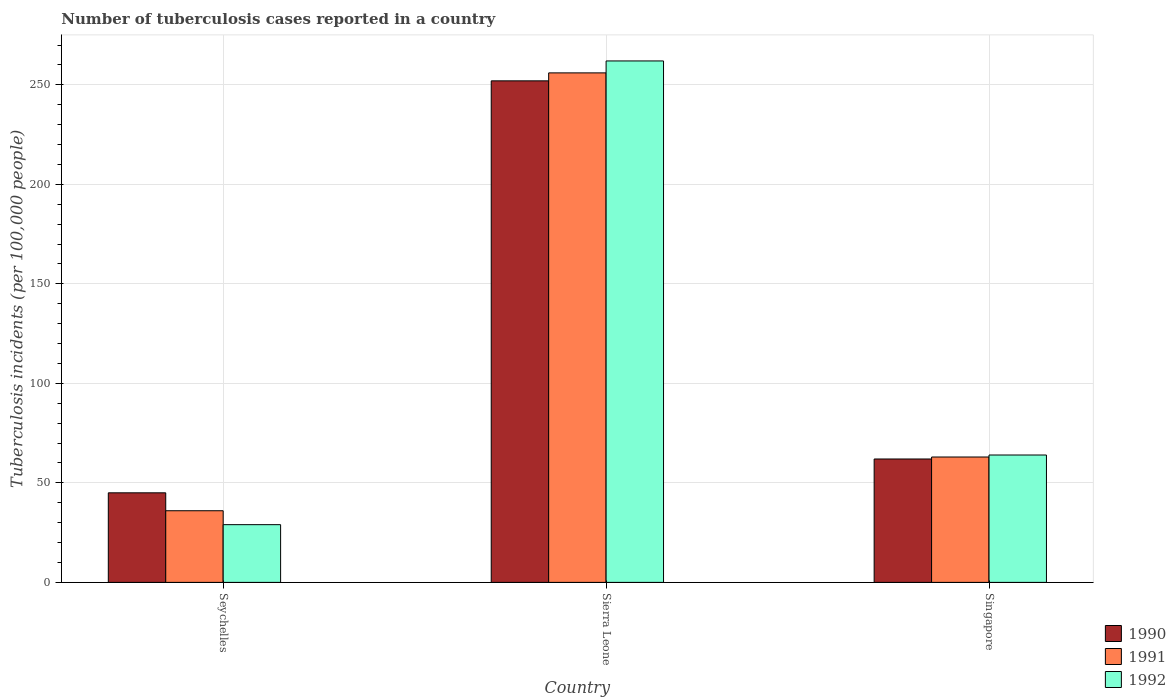Are the number of bars on each tick of the X-axis equal?
Your answer should be very brief. Yes. How many bars are there on the 2nd tick from the right?
Offer a very short reply. 3. What is the label of the 3rd group of bars from the left?
Your response must be concise. Singapore. In how many cases, is the number of bars for a given country not equal to the number of legend labels?
Offer a terse response. 0. What is the number of tuberculosis cases reported in in 1990 in Sierra Leone?
Your answer should be compact. 252. Across all countries, what is the maximum number of tuberculosis cases reported in in 1991?
Your answer should be compact. 256. Across all countries, what is the minimum number of tuberculosis cases reported in in 1990?
Ensure brevity in your answer.  45. In which country was the number of tuberculosis cases reported in in 1992 maximum?
Give a very brief answer. Sierra Leone. In which country was the number of tuberculosis cases reported in in 1990 minimum?
Offer a very short reply. Seychelles. What is the total number of tuberculosis cases reported in in 1992 in the graph?
Your response must be concise. 355. What is the difference between the number of tuberculosis cases reported in in 1992 in Seychelles and that in Sierra Leone?
Your response must be concise. -233. What is the difference between the number of tuberculosis cases reported in in 1990 in Sierra Leone and the number of tuberculosis cases reported in in 1991 in Singapore?
Ensure brevity in your answer.  189. What is the average number of tuberculosis cases reported in in 1991 per country?
Give a very brief answer. 118.33. What is the ratio of the number of tuberculosis cases reported in in 1990 in Seychelles to that in Sierra Leone?
Your response must be concise. 0.18. Is the number of tuberculosis cases reported in in 1990 in Seychelles less than that in Singapore?
Ensure brevity in your answer.  Yes. Is the difference between the number of tuberculosis cases reported in in 1992 in Seychelles and Singapore greater than the difference between the number of tuberculosis cases reported in in 1991 in Seychelles and Singapore?
Keep it short and to the point. No. What is the difference between the highest and the second highest number of tuberculosis cases reported in in 1991?
Offer a very short reply. 220. What is the difference between the highest and the lowest number of tuberculosis cases reported in in 1990?
Your answer should be very brief. 207. In how many countries, is the number of tuberculosis cases reported in in 1991 greater than the average number of tuberculosis cases reported in in 1991 taken over all countries?
Provide a short and direct response. 1. What does the 2nd bar from the right in Singapore represents?
Provide a short and direct response. 1991. How many countries are there in the graph?
Provide a succinct answer. 3. Does the graph contain any zero values?
Your answer should be very brief. No. Does the graph contain grids?
Your answer should be very brief. Yes. What is the title of the graph?
Offer a very short reply. Number of tuberculosis cases reported in a country. Does "1991" appear as one of the legend labels in the graph?
Your answer should be very brief. Yes. What is the label or title of the X-axis?
Provide a succinct answer. Country. What is the label or title of the Y-axis?
Your answer should be compact. Tuberculosis incidents (per 100,0 people). What is the Tuberculosis incidents (per 100,000 people) of 1990 in Seychelles?
Your answer should be very brief. 45. What is the Tuberculosis incidents (per 100,000 people) of 1991 in Seychelles?
Your answer should be very brief. 36. What is the Tuberculosis incidents (per 100,000 people) of 1992 in Seychelles?
Your answer should be very brief. 29. What is the Tuberculosis incidents (per 100,000 people) of 1990 in Sierra Leone?
Provide a succinct answer. 252. What is the Tuberculosis incidents (per 100,000 people) in 1991 in Sierra Leone?
Offer a terse response. 256. What is the Tuberculosis incidents (per 100,000 people) in 1992 in Sierra Leone?
Your response must be concise. 262. What is the Tuberculosis incidents (per 100,000 people) of 1991 in Singapore?
Give a very brief answer. 63. Across all countries, what is the maximum Tuberculosis incidents (per 100,000 people) of 1990?
Provide a short and direct response. 252. Across all countries, what is the maximum Tuberculosis incidents (per 100,000 people) of 1991?
Your answer should be compact. 256. Across all countries, what is the maximum Tuberculosis incidents (per 100,000 people) in 1992?
Your response must be concise. 262. What is the total Tuberculosis incidents (per 100,000 people) in 1990 in the graph?
Give a very brief answer. 359. What is the total Tuberculosis incidents (per 100,000 people) of 1991 in the graph?
Your answer should be very brief. 355. What is the total Tuberculosis incidents (per 100,000 people) of 1992 in the graph?
Provide a short and direct response. 355. What is the difference between the Tuberculosis incidents (per 100,000 people) of 1990 in Seychelles and that in Sierra Leone?
Provide a succinct answer. -207. What is the difference between the Tuberculosis incidents (per 100,000 people) in 1991 in Seychelles and that in Sierra Leone?
Offer a very short reply. -220. What is the difference between the Tuberculosis incidents (per 100,000 people) of 1992 in Seychelles and that in Sierra Leone?
Make the answer very short. -233. What is the difference between the Tuberculosis incidents (per 100,000 people) in 1991 in Seychelles and that in Singapore?
Ensure brevity in your answer.  -27. What is the difference between the Tuberculosis incidents (per 100,000 people) in 1992 in Seychelles and that in Singapore?
Provide a short and direct response. -35. What is the difference between the Tuberculosis incidents (per 100,000 people) in 1990 in Sierra Leone and that in Singapore?
Your answer should be compact. 190. What is the difference between the Tuberculosis incidents (per 100,000 people) in 1991 in Sierra Leone and that in Singapore?
Your answer should be very brief. 193. What is the difference between the Tuberculosis incidents (per 100,000 people) of 1992 in Sierra Leone and that in Singapore?
Make the answer very short. 198. What is the difference between the Tuberculosis incidents (per 100,000 people) of 1990 in Seychelles and the Tuberculosis incidents (per 100,000 people) of 1991 in Sierra Leone?
Keep it short and to the point. -211. What is the difference between the Tuberculosis incidents (per 100,000 people) in 1990 in Seychelles and the Tuberculosis incidents (per 100,000 people) in 1992 in Sierra Leone?
Offer a very short reply. -217. What is the difference between the Tuberculosis incidents (per 100,000 people) in 1991 in Seychelles and the Tuberculosis incidents (per 100,000 people) in 1992 in Sierra Leone?
Make the answer very short. -226. What is the difference between the Tuberculosis incidents (per 100,000 people) in 1990 in Sierra Leone and the Tuberculosis incidents (per 100,000 people) in 1991 in Singapore?
Make the answer very short. 189. What is the difference between the Tuberculosis incidents (per 100,000 people) in 1990 in Sierra Leone and the Tuberculosis incidents (per 100,000 people) in 1992 in Singapore?
Ensure brevity in your answer.  188. What is the difference between the Tuberculosis incidents (per 100,000 people) of 1991 in Sierra Leone and the Tuberculosis incidents (per 100,000 people) of 1992 in Singapore?
Provide a succinct answer. 192. What is the average Tuberculosis incidents (per 100,000 people) of 1990 per country?
Provide a succinct answer. 119.67. What is the average Tuberculosis incidents (per 100,000 people) of 1991 per country?
Provide a succinct answer. 118.33. What is the average Tuberculosis incidents (per 100,000 people) of 1992 per country?
Your answer should be compact. 118.33. What is the difference between the Tuberculosis incidents (per 100,000 people) in 1990 and Tuberculosis incidents (per 100,000 people) in 1991 in Seychelles?
Your answer should be compact. 9. What is the difference between the Tuberculosis incidents (per 100,000 people) of 1991 and Tuberculosis incidents (per 100,000 people) of 1992 in Seychelles?
Offer a terse response. 7. What is the difference between the Tuberculosis incidents (per 100,000 people) in 1990 and Tuberculosis incidents (per 100,000 people) in 1992 in Sierra Leone?
Your answer should be compact. -10. What is the difference between the Tuberculosis incidents (per 100,000 people) in 1990 and Tuberculosis incidents (per 100,000 people) in 1991 in Singapore?
Give a very brief answer. -1. What is the difference between the Tuberculosis incidents (per 100,000 people) of 1991 and Tuberculosis incidents (per 100,000 people) of 1992 in Singapore?
Keep it short and to the point. -1. What is the ratio of the Tuberculosis incidents (per 100,000 people) in 1990 in Seychelles to that in Sierra Leone?
Give a very brief answer. 0.18. What is the ratio of the Tuberculosis incidents (per 100,000 people) in 1991 in Seychelles to that in Sierra Leone?
Give a very brief answer. 0.14. What is the ratio of the Tuberculosis incidents (per 100,000 people) of 1992 in Seychelles to that in Sierra Leone?
Make the answer very short. 0.11. What is the ratio of the Tuberculosis incidents (per 100,000 people) of 1990 in Seychelles to that in Singapore?
Your answer should be very brief. 0.73. What is the ratio of the Tuberculosis incidents (per 100,000 people) of 1992 in Seychelles to that in Singapore?
Your answer should be compact. 0.45. What is the ratio of the Tuberculosis incidents (per 100,000 people) of 1990 in Sierra Leone to that in Singapore?
Offer a terse response. 4.06. What is the ratio of the Tuberculosis incidents (per 100,000 people) in 1991 in Sierra Leone to that in Singapore?
Your answer should be compact. 4.06. What is the ratio of the Tuberculosis incidents (per 100,000 people) in 1992 in Sierra Leone to that in Singapore?
Ensure brevity in your answer.  4.09. What is the difference between the highest and the second highest Tuberculosis incidents (per 100,000 people) in 1990?
Make the answer very short. 190. What is the difference between the highest and the second highest Tuberculosis incidents (per 100,000 people) in 1991?
Your answer should be compact. 193. What is the difference between the highest and the second highest Tuberculosis incidents (per 100,000 people) in 1992?
Keep it short and to the point. 198. What is the difference between the highest and the lowest Tuberculosis incidents (per 100,000 people) in 1990?
Offer a terse response. 207. What is the difference between the highest and the lowest Tuberculosis incidents (per 100,000 people) of 1991?
Give a very brief answer. 220. What is the difference between the highest and the lowest Tuberculosis incidents (per 100,000 people) of 1992?
Make the answer very short. 233. 